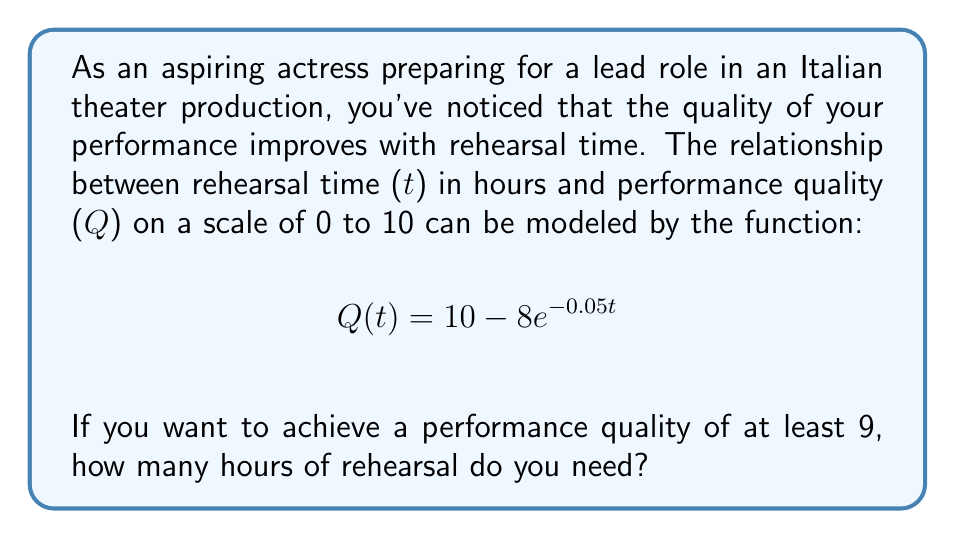Show me your answer to this math problem. To solve this problem, we need to follow these steps:

1) We want to find t when Q(t) ≥ 9. So, let's set up the inequality:

   $$10 - 8e^{-0.05t} \geq 9$$

2) Subtract 10 from both sides:

   $$-8e^{-0.05t} \geq -1$$

3) Divide both sides by -8:

   $$e^{-0.05t} \leq \frac{1}{8}$$

4) Take the natural logarithm of both sides:

   $$-0.05t \leq \ln(\frac{1}{8})$$

5) Divide both sides by -0.05:

   $$t \geq -\frac{\ln(\frac{1}{8})}{0.05}$$

6) Simplify:

   $$t \geq -\frac{\ln(1) - \ln(8)}{0.05} = \frac{\ln(8)}{0.05}$$

7) Calculate the result:

   $$t \geq \frac{2.0794}{0.05} \approx 41.59$$

Therefore, you need at least 41.59 hours of rehearsal to achieve a performance quality of 9 or higher.
Answer: 41.59 hours 